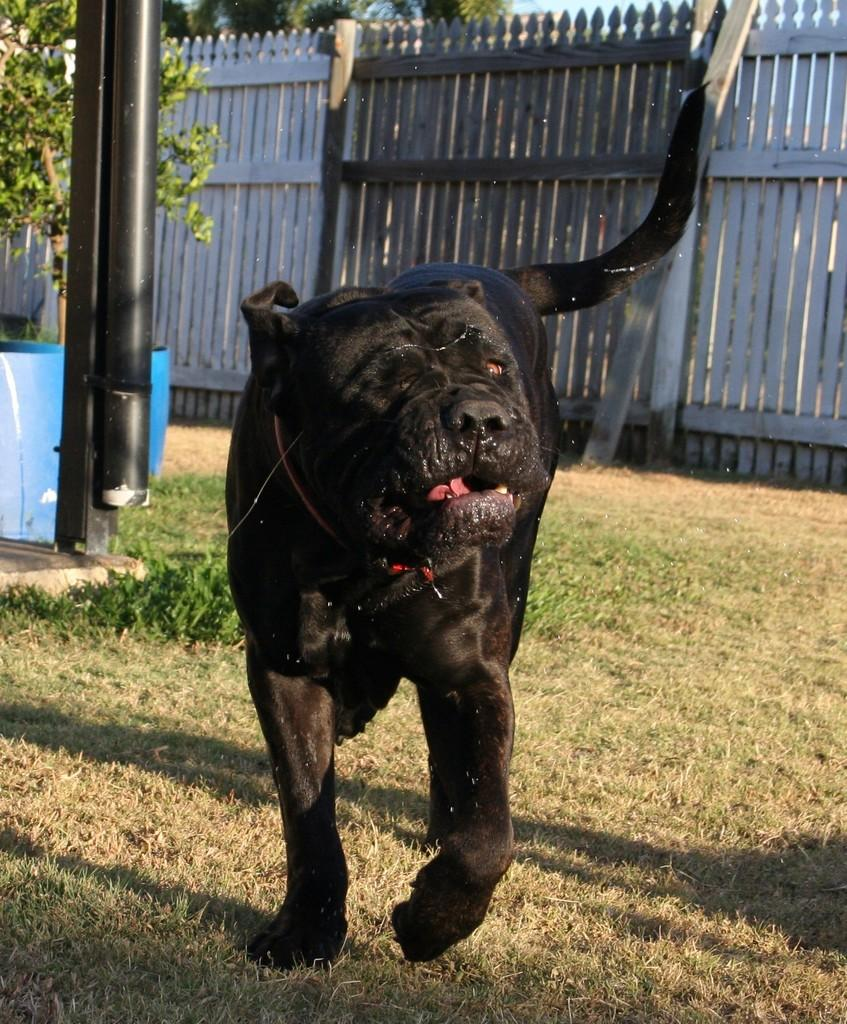What animal is present in the image? There is a dog standing on the ground in the image. What is the surface of the ground in the image? The ground is covered with grass. What can be seen in the background of the image? There is a plant in a pot in the background of the image. What type of fencing is visible in the image? There is a wooden fencing in the image. What type of basket is the dog carrying in its mouth in the image? There is no basket or mouth visible in the image; the dog is standing on the ground. 